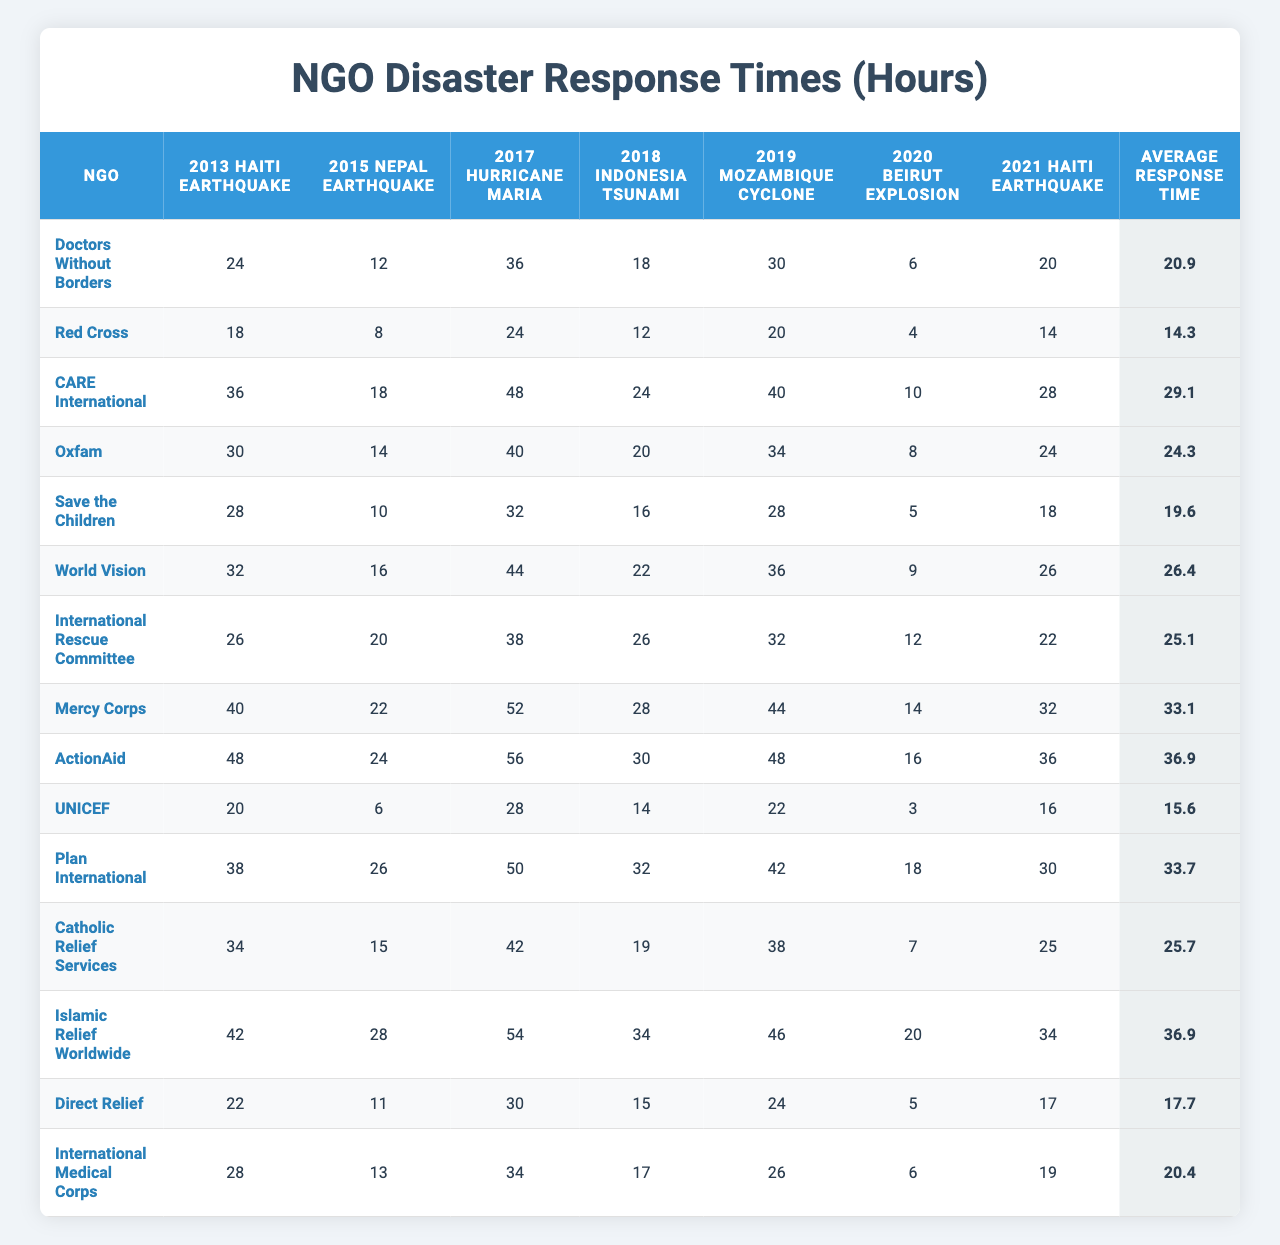What was the response time of UNICEF during the 2020 Beirut Explosion? Looking at the row for UNICEF in the table, the response time for the 2020 Beirut Explosion is 18 hours.
Answer: 18 hours Which NGO had the longest average response time? By reviewing the "Average Response Time" column, it shows that CARE International has the longest average response time of 29.1 hours.
Answer: CARE International Was the response time for the 2017 Hurricane Maria shorter for Doctors Without Borders than for Red Cross? In the table, the response time for Doctors Without Borders during the 2017 Hurricane Maria is 36 hours, while for Red Cross it is 24 hours, indicating that Doctors Without Borders had a longer response time.
Answer: No What was the total response time for Mercy Corps during the disasters listed? To calculate the total response time for Mercy Corps, we sum the response times for each disaster: 40 + 22 + 52 + 28 + 36 + 14 + 32 + 44 = 274 hours.
Answer: 274 hours Which NGO had the quickest response time in the 2015 Nepal Earthquake, and what was it? From the 2015 Nepal Earthquake data in the table, the quickest response time is held by Red Cross at 8 hours.
Answer: Red Cross, 8 hours How does the average response time for Save the Children compare to that of World Vision? The average response time for Save the Children is 19.6 hours, while for World Vision it is 26.4 hours. Comparing these, Save the Children has a shorter average response time.
Answer: Save the Children has a shorter average response time If you combine the response times for the 2013 Haiti Earthquake and 2015 Nepal Earthquake for ActionAid, what is the sum? The response times for ActionAid in these two disasters are 48 hours for the 2013 Haiti Earthquake and 24 hours for the 2015 Nepal Earthquake. Adding these gives 48 + 24 = 72 hours.
Answer: 72 hours Which NGO responded quickest to the 2021 Haiti Earthquake, and what was their response time? By examining the 2021 Haiti Earthquake row, it is evident that Red Cross had the quickest response time of 14 hours.
Answer: Red Cross, 14 hours Is the average response time for the International Rescue Committee greater or less than 25 hours? The average response time for the International Rescue Committee is 25.1 hours, which is greater than 25 hours.
Answer: Greater than 25 hours Which NGO had the second longest response time during the 2019 Mozambique Cyclone, and what was it? The row for the 2019 Mozambique Cyclone shows that the second longest response time is for Save the Children at 28 hours, following CARE International at 34 hours.
Answer: Save the Children, 28 hours 